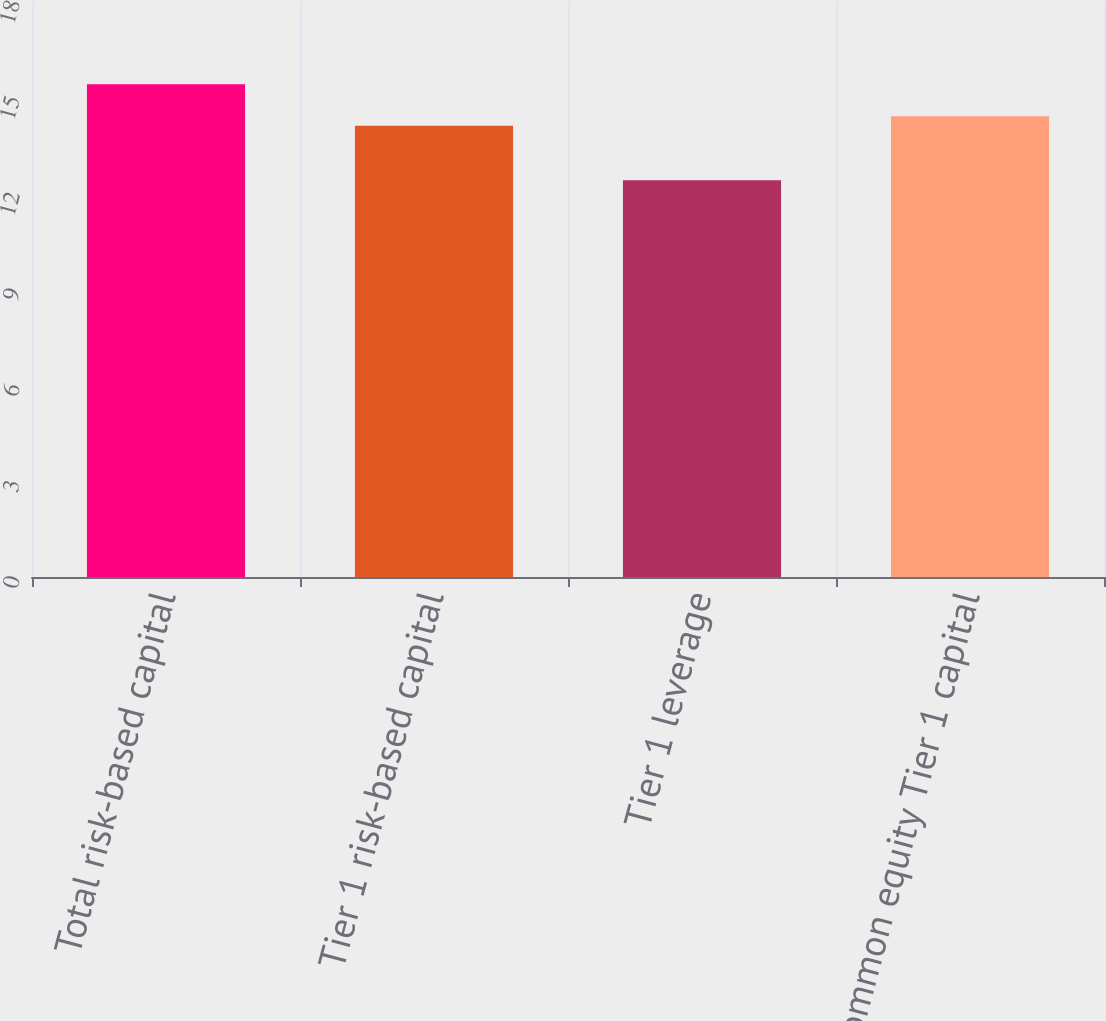Convert chart. <chart><loc_0><loc_0><loc_500><loc_500><bar_chart><fcel>Total risk-based capital<fcel>Tier 1 risk-based capital<fcel>Tier 1 leverage<fcel>Common equity Tier 1 capital<nl><fcel>15.4<fcel>14.1<fcel>12.4<fcel>14.4<nl></chart> 